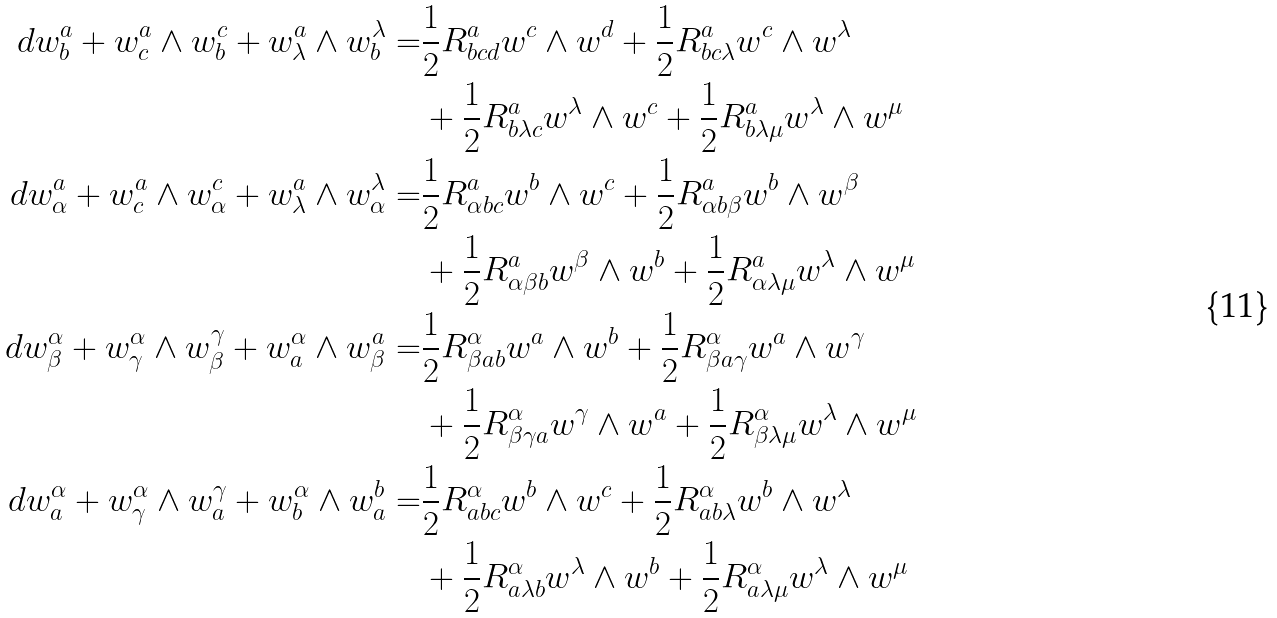<formula> <loc_0><loc_0><loc_500><loc_500>d w _ { b } ^ { a } + w _ { c } ^ { a } \wedge w _ { b } ^ { c } + w _ { \lambda } ^ { a } \wedge w _ { b } ^ { \lambda } = & \frac { 1 } { 2 } R _ { b c d } ^ { a } w ^ { c } \wedge w ^ { d } + \frac { 1 } { 2 } R _ { b c \lambda } ^ { a } w ^ { c } \wedge w ^ { \lambda } \\ & + \frac { 1 } { 2 } R _ { b \lambda c } ^ { a } w ^ { \lambda } \wedge w ^ { c } + \frac { 1 } { 2 } R _ { b \lambda \mu } ^ { a } w ^ { \lambda } \wedge w ^ { \mu } \\ d w _ { \alpha } ^ { a } + w _ { c } ^ { a } \wedge w _ { \alpha } ^ { c } + w _ { \lambda } ^ { a } \wedge w _ { \alpha } ^ { \lambda } = & \frac { 1 } { 2 } R _ { \alpha b c } ^ { a } w ^ { b } \wedge w ^ { c } + \frac { 1 } { 2 } R _ { \alpha b \beta } ^ { a } w ^ { b } \wedge w ^ { \beta } \\ & + \frac { 1 } { 2 } R _ { \alpha \beta b } ^ { a } w ^ { \beta } \wedge w ^ { b } + \frac { 1 } { 2 } R _ { \alpha \lambda \mu } ^ { a } w ^ { \lambda } \wedge w ^ { \mu } \\ d w _ { \beta } ^ { \alpha } + w _ { \gamma } ^ { \alpha } \wedge w _ { \beta } ^ { \gamma } + w _ { a } ^ { \alpha } \wedge w _ { \beta } ^ { a } = & \frac { 1 } { 2 } R _ { \beta a b } ^ { \alpha } w ^ { a } \wedge w ^ { b } + \frac { 1 } { 2 } R _ { \beta a \gamma } ^ { \alpha } w ^ { a } \wedge w ^ { \gamma } \\ & + \frac { 1 } { 2 } R _ { \beta \gamma a } ^ { \alpha } w ^ { \gamma } \wedge w ^ { a } + \frac { 1 } { 2 } R _ { \beta \lambda \mu } ^ { \alpha } w ^ { \lambda } \wedge w ^ { \mu } \\ d w _ { a } ^ { \alpha } + w _ { \gamma } ^ { \alpha } \wedge w _ { a } ^ { \gamma } + w _ { b } ^ { \alpha } \wedge w _ { a } ^ { b } = & \frac { 1 } { 2 } R _ { a b c } ^ { \alpha } w ^ { b } \wedge w ^ { c } + \frac { 1 } { 2 } R _ { a b \lambda } ^ { \alpha } w ^ { b } \wedge w ^ { \lambda } \\ & + \frac { 1 } { 2 } R _ { a \lambda b } ^ { \alpha } w ^ { \lambda } \wedge w ^ { b } + \frac { 1 } { 2 } R _ { a \lambda \mu } ^ { \alpha } w ^ { \lambda } \wedge w ^ { \mu }</formula> 